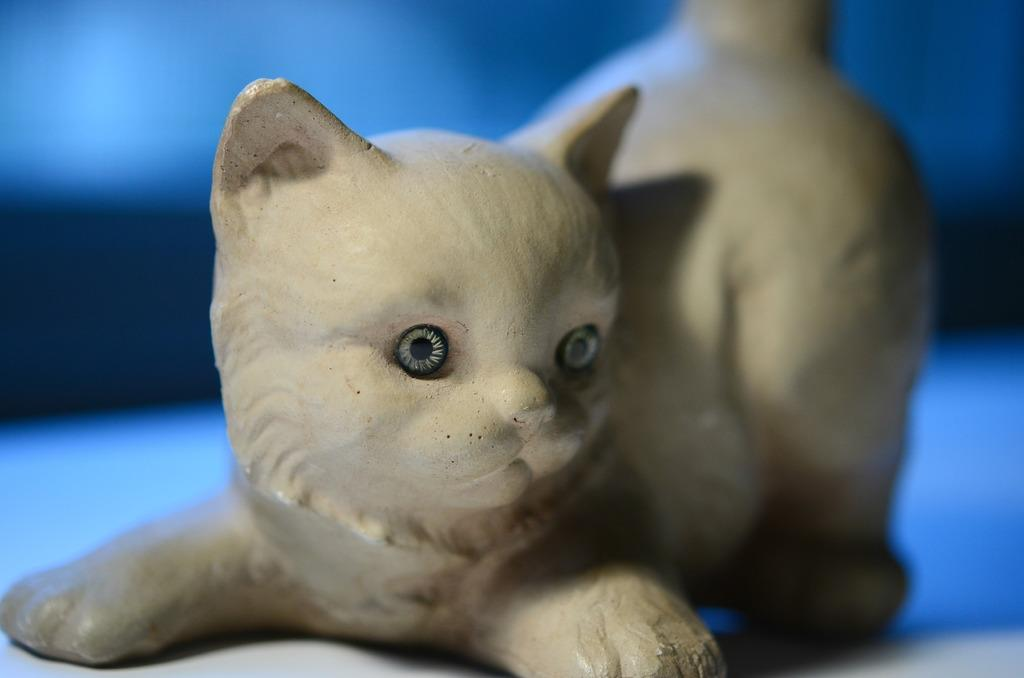What type of object is the main subject of the image? There is a wooden carved cat in the image. What type of surface is visible in the image? There is a floor visible in the image. What type of card is being used to clean the linen in the image? There is no card or linen present in the image; it features a wooden carved cat and a floor. 